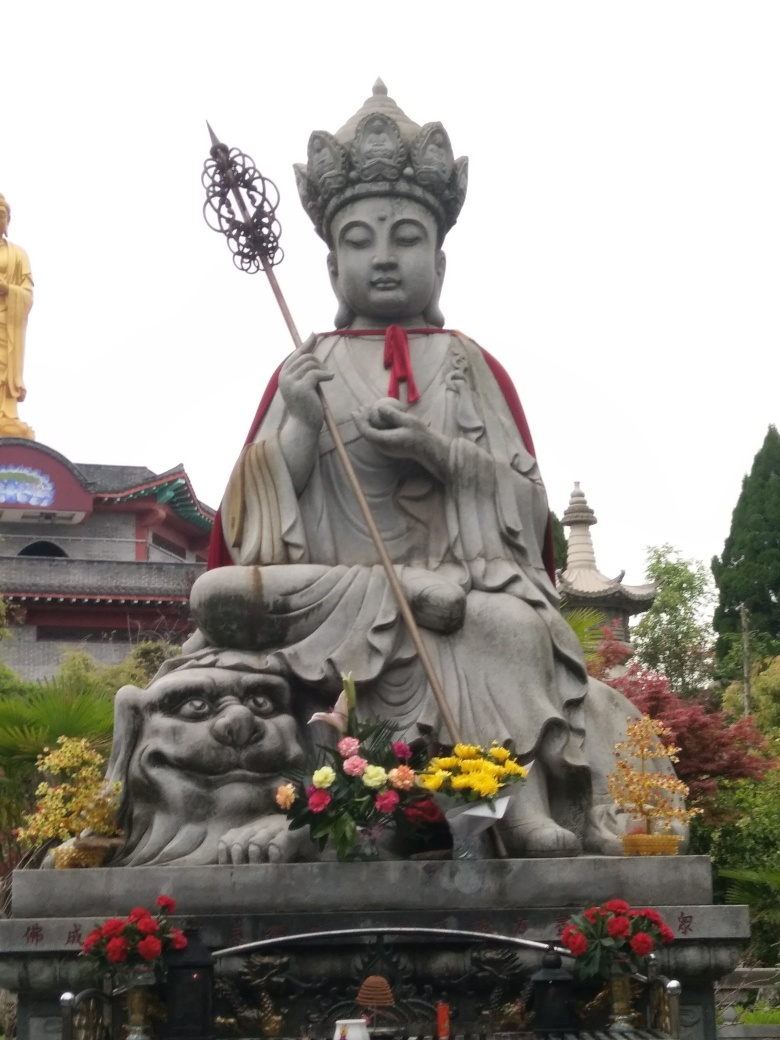Is the main subject clear in the image? A. Fairly clear B. Slightly blurry C. Completely unclear D. Very blurry Answer with the option's letter from the given choices directly. The main subject of the image, which appears to be a statue of a figure, is fairly clear with distinct features and details visible. The image resolution seems adequate for discernment, and there's no notable blur that obscures the main subject, making option A the most accurate choice. 